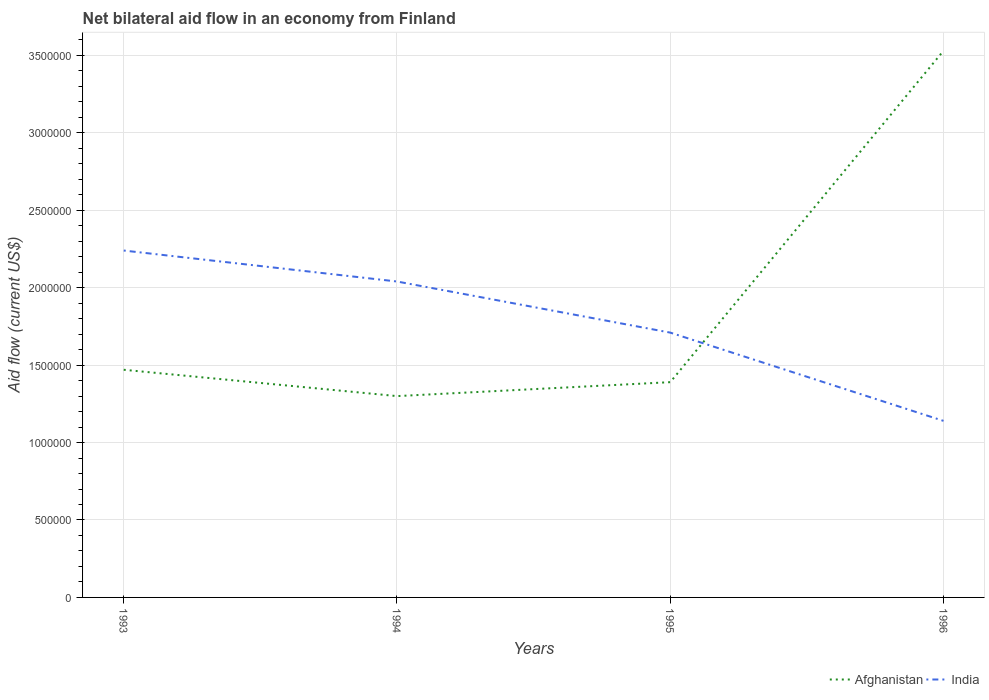Does the line corresponding to Afghanistan intersect with the line corresponding to India?
Provide a short and direct response. Yes. Across all years, what is the maximum net bilateral aid flow in Afghanistan?
Provide a succinct answer. 1.30e+06. What is the total net bilateral aid flow in India in the graph?
Provide a succinct answer. 1.10e+06. What is the difference between the highest and the second highest net bilateral aid flow in India?
Ensure brevity in your answer.  1.10e+06. What is the difference between the highest and the lowest net bilateral aid flow in Afghanistan?
Ensure brevity in your answer.  1. Is the net bilateral aid flow in Afghanistan strictly greater than the net bilateral aid flow in India over the years?
Ensure brevity in your answer.  No. Are the values on the major ticks of Y-axis written in scientific E-notation?
Provide a short and direct response. No. What is the title of the graph?
Your response must be concise. Net bilateral aid flow in an economy from Finland. What is the Aid flow (current US$) in Afghanistan in 1993?
Give a very brief answer. 1.47e+06. What is the Aid flow (current US$) in India in 1993?
Make the answer very short. 2.24e+06. What is the Aid flow (current US$) of Afghanistan in 1994?
Your response must be concise. 1.30e+06. What is the Aid flow (current US$) in India in 1994?
Your answer should be very brief. 2.04e+06. What is the Aid flow (current US$) in Afghanistan in 1995?
Your answer should be very brief. 1.39e+06. What is the Aid flow (current US$) of India in 1995?
Provide a succinct answer. 1.71e+06. What is the Aid flow (current US$) in Afghanistan in 1996?
Give a very brief answer. 3.53e+06. What is the Aid flow (current US$) in India in 1996?
Provide a succinct answer. 1.14e+06. Across all years, what is the maximum Aid flow (current US$) of Afghanistan?
Provide a succinct answer. 3.53e+06. Across all years, what is the maximum Aid flow (current US$) in India?
Ensure brevity in your answer.  2.24e+06. Across all years, what is the minimum Aid flow (current US$) of Afghanistan?
Offer a very short reply. 1.30e+06. Across all years, what is the minimum Aid flow (current US$) in India?
Your response must be concise. 1.14e+06. What is the total Aid flow (current US$) in Afghanistan in the graph?
Provide a succinct answer. 7.69e+06. What is the total Aid flow (current US$) of India in the graph?
Keep it short and to the point. 7.13e+06. What is the difference between the Aid flow (current US$) in Afghanistan in 1993 and that in 1994?
Provide a short and direct response. 1.70e+05. What is the difference between the Aid flow (current US$) in India in 1993 and that in 1995?
Keep it short and to the point. 5.30e+05. What is the difference between the Aid flow (current US$) of Afghanistan in 1993 and that in 1996?
Offer a very short reply. -2.06e+06. What is the difference between the Aid flow (current US$) in India in 1993 and that in 1996?
Your response must be concise. 1.10e+06. What is the difference between the Aid flow (current US$) in India in 1994 and that in 1995?
Make the answer very short. 3.30e+05. What is the difference between the Aid flow (current US$) of Afghanistan in 1994 and that in 1996?
Your response must be concise. -2.23e+06. What is the difference between the Aid flow (current US$) in India in 1994 and that in 1996?
Make the answer very short. 9.00e+05. What is the difference between the Aid flow (current US$) in Afghanistan in 1995 and that in 1996?
Offer a very short reply. -2.14e+06. What is the difference between the Aid flow (current US$) of India in 1995 and that in 1996?
Your response must be concise. 5.70e+05. What is the difference between the Aid flow (current US$) in Afghanistan in 1993 and the Aid flow (current US$) in India in 1994?
Ensure brevity in your answer.  -5.70e+05. What is the difference between the Aid flow (current US$) of Afghanistan in 1993 and the Aid flow (current US$) of India in 1995?
Offer a terse response. -2.40e+05. What is the difference between the Aid flow (current US$) of Afghanistan in 1994 and the Aid flow (current US$) of India in 1995?
Provide a short and direct response. -4.10e+05. What is the difference between the Aid flow (current US$) in Afghanistan in 1994 and the Aid flow (current US$) in India in 1996?
Ensure brevity in your answer.  1.60e+05. What is the average Aid flow (current US$) in Afghanistan per year?
Make the answer very short. 1.92e+06. What is the average Aid flow (current US$) in India per year?
Provide a succinct answer. 1.78e+06. In the year 1993, what is the difference between the Aid flow (current US$) in Afghanistan and Aid flow (current US$) in India?
Keep it short and to the point. -7.70e+05. In the year 1994, what is the difference between the Aid flow (current US$) of Afghanistan and Aid flow (current US$) of India?
Your answer should be very brief. -7.40e+05. In the year 1995, what is the difference between the Aid flow (current US$) of Afghanistan and Aid flow (current US$) of India?
Your answer should be compact. -3.20e+05. In the year 1996, what is the difference between the Aid flow (current US$) of Afghanistan and Aid flow (current US$) of India?
Offer a terse response. 2.39e+06. What is the ratio of the Aid flow (current US$) of Afghanistan in 1993 to that in 1994?
Provide a succinct answer. 1.13. What is the ratio of the Aid flow (current US$) in India in 1993 to that in 1994?
Ensure brevity in your answer.  1.1. What is the ratio of the Aid flow (current US$) of Afghanistan in 1993 to that in 1995?
Give a very brief answer. 1.06. What is the ratio of the Aid flow (current US$) in India in 1993 to that in 1995?
Provide a succinct answer. 1.31. What is the ratio of the Aid flow (current US$) in Afghanistan in 1993 to that in 1996?
Keep it short and to the point. 0.42. What is the ratio of the Aid flow (current US$) in India in 1993 to that in 1996?
Keep it short and to the point. 1.96. What is the ratio of the Aid flow (current US$) of Afghanistan in 1994 to that in 1995?
Ensure brevity in your answer.  0.94. What is the ratio of the Aid flow (current US$) of India in 1994 to that in 1995?
Keep it short and to the point. 1.19. What is the ratio of the Aid flow (current US$) of Afghanistan in 1994 to that in 1996?
Your answer should be compact. 0.37. What is the ratio of the Aid flow (current US$) in India in 1994 to that in 1996?
Make the answer very short. 1.79. What is the ratio of the Aid flow (current US$) of Afghanistan in 1995 to that in 1996?
Ensure brevity in your answer.  0.39. What is the difference between the highest and the second highest Aid flow (current US$) in Afghanistan?
Keep it short and to the point. 2.06e+06. What is the difference between the highest and the lowest Aid flow (current US$) in Afghanistan?
Provide a succinct answer. 2.23e+06. What is the difference between the highest and the lowest Aid flow (current US$) of India?
Give a very brief answer. 1.10e+06. 